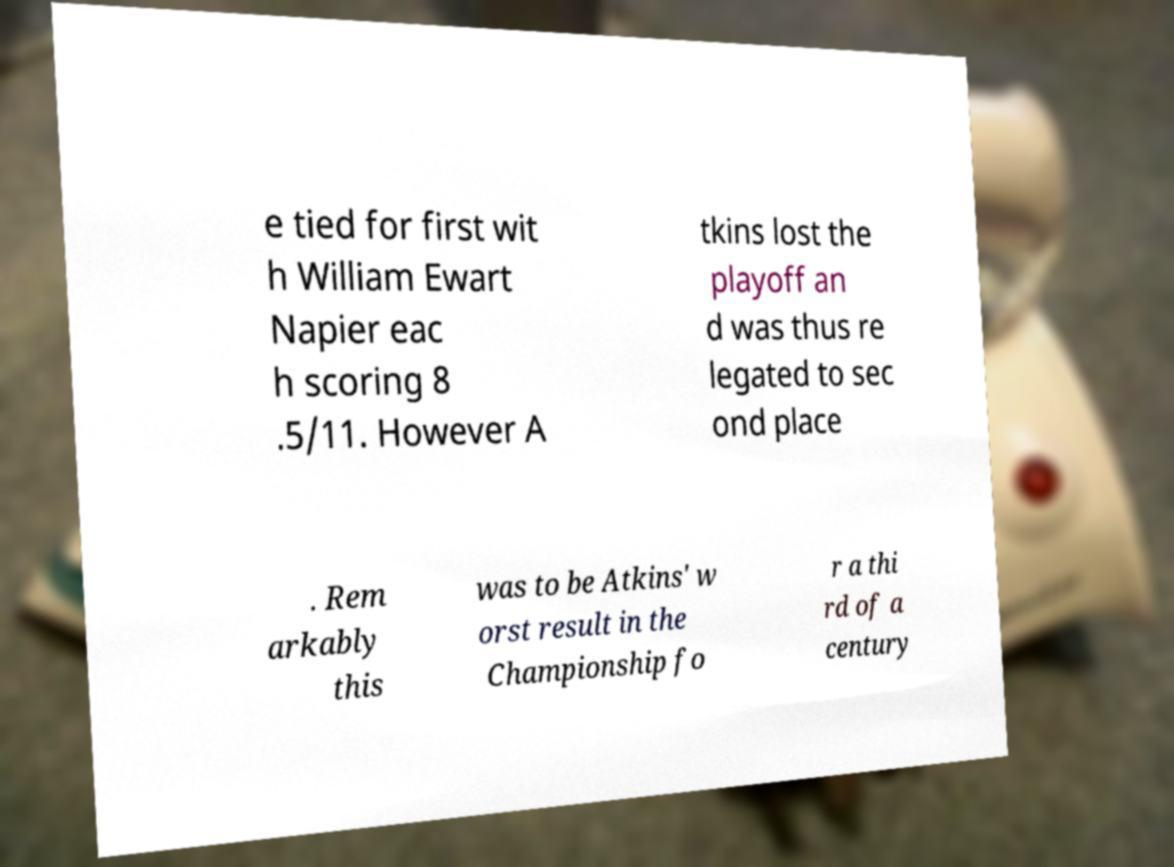Please read and relay the text visible in this image. What does it say? e tied for first wit h William Ewart Napier eac h scoring 8 .5/11. However A tkins lost the playoff an d was thus re legated to sec ond place . Rem arkably this was to be Atkins' w orst result in the Championship fo r a thi rd of a century 